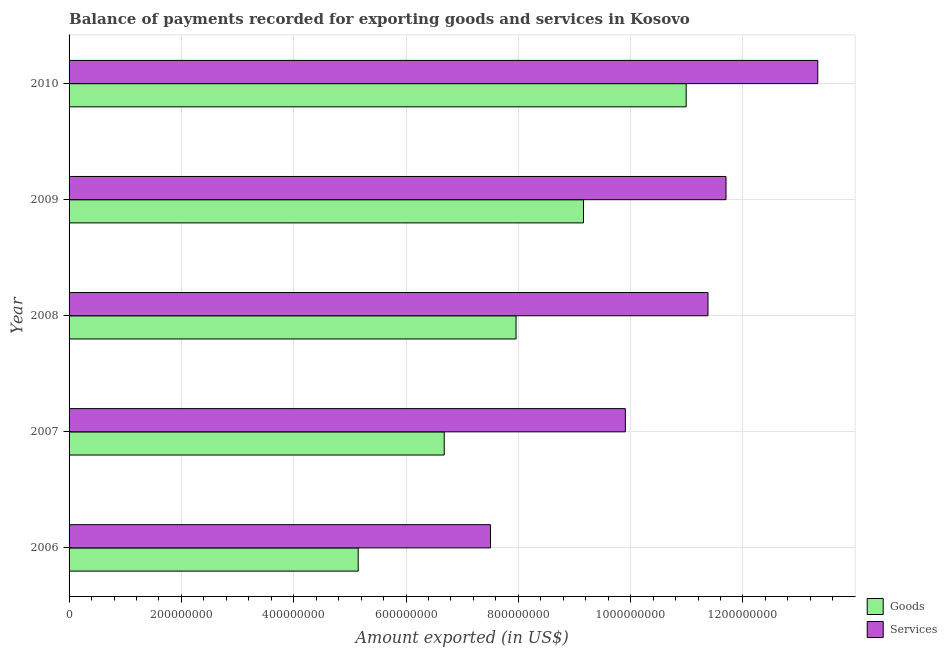How many different coloured bars are there?
Give a very brief answer. 2. How many groups of bars are there?
Provide a short and direct response. 5. Are the number of bars per tick equal to the number of legend labels?
Provide a short and direct response. Yes. Are the number of bars on each tick of the Y-axis equal?
Your response must be concise. Yes. What is the amount of services exported in 2007?
Give a very brief answer. 9.91e+08. Across all years, what is the maximum amount of goods exported?
Your response must be concise. 1.10e+09. Across all years, what is the minimum amount of goods exported?
Ensure brevity in your answer.  5.15e+08. In which year was the amount of goods exported maximum?
Provide a succinct answer. 2010. In which year was the amount of goods exported minimum?
Provide a succinct answer. 2006. What is the total amount of services exported in the graph?
Ensure brevity in your answer.  5.38e+09. What is the difference between the amount of services exported in 2007 and that in 2008?
Offer a terse response. -1.47e+08. What is the difference between the amount of services exported in 2008 and the amount of goods exported in 2010?
Offer a very short reply. 3.89e+07. What is the average amount of services exported per year?
Make the answer very short. 1.08e+09. In the year 2010, what is the difference between the amount of services exported and amount of goods exported?
Provide a short and direct response. 2.34e+08. What is the ratio of the amount of services exported in 2006 to that in 2008?
Provide a short and direct response. 0.66. Is the difference between the amount of goods exported in 2008 and 2009 greater than the difference between the amount of services exported in 2008 and 2009?
Offer a terse response. No. What is the difference between the highest and the second highest amount of services exported?
Provide a short and direct response. 1.63e+08. What is the difference between the highest and the lowest amount of goods exported?
Provide a short and direct response. 5.84e+08. Is the sum of the amount of services exported in 2008 and 2010 greater than the maximum amount of goods exported across all years?
Offer a very short reply. Yes. What does the 1st bar from the top in 2008 represents?
Keep it short and to the point. Services. What does the 2nd bar from the bottom in 2010 represents?
Provide a short and direct response. Services. How many bars are there?
Give a very brief answer. 10. What is the difference between two consecutive major ticks on the X-axis?
Offer a very short reply. 2.00e+08. Does the graph contain any zero values?
Ensure brevity in your answer.  No. How many legend labels are there?
Offer a terse response. 2. What is the title of the graph?
Make the answer very short. Balance of payments recorded for exporting goods and services in Kosovo. Does "Underweight" appear as one of the legend labels in the graph?
Ensure brevity in your answer.  No. What is the label or title of the X-axis?
Provide a succinct answer. Amount exported (in US$). What is the Amount exported (in US$) in Goods in 2006?
Offer a terse response. 5.15e+08. What is the Amount exported (in US$) of Services in 2006?
Ensure brevity in your answer.  7.50e+08. What is the Amount exported (in US$) in Goods in 2007?
Ensure brevity in your answer.  6.68e+08. What is the Amount exported (in US$) in Services in 2007?
Provide a short and direct response. 9.91e+08. What is the Amount exported (in US$) of Goods in 2008?
Your answer should be compact. 7.96e+08. What is the Amount exported (in US$) in Services in 2008?
Keep it short and to the point. 1.14e+09. What is the Amount exported (in US$) of Goods in 2009?
Make the answer very short. 9.16e+08. What is the Amount exported (in US$) in Services in 2009?
Provide a short and direct response. 1.17e+09. What is the Amount exported (in US$) in Goods in 2010?
Offer a very short reply. 1.10e+09. What is the Amount exported (in US$) of Services in 2010?
Provide a short and direct response. 1.33e+09. Across all years, what is the maximum Amount exported (in US$) of Goods?
Your response must be concise. 1.10e+09. Across all years, what is the maximum Amount exported (in US$) of Services?
Offer a very short reply. 1.33e+09. Across all years, what is the minimum Amount exported (in US$) in Goods?
Give a very brief answer. 5.15e+08. Across all years, what is the minimum Amount exported (in US$) in Services?
Make the answer very short. 7.50e+08. What is the total Amount exported (in US$) in Goods in the graph?
Your answer should be very brief. 3.99e+09. What is the total Amount exported (in US$) in Services in the graph?
Offer a very short reply. 5.38e+09. What is the difference between the Amount exported (in US$) of Goods in 2006 and that in 2007?
Your response must be concise. -1.53e+08. What is the difference between the Amount exported (in US$) of Services in 2006 and that in 2007?
Keep it short and to the point. -2.40e+08. What is the difference between the Amount exported (in US$) of Goods in 2006 and that in 2008?
Your response must be concise. -2.81e+08. What is the difference between the Amount exported (in US$) of Services in 2006 and that in 2008?
Provide a succinct answer. -3.87e+08. What is the difference between the Amount exported (in US$) in Goods in 2006 and that in 2009?
Provide a short and direct response. -4.01e+08. What is the difference between the Amount exported (in US$) in Services in 2006 and that in 2009?
Make the answer very short. -4.19e+08. What is the difference between the Amount exported (in US$) in Goods in 2006 and that in 2010?
Your response must be concise. -5.84e+08. What is the difference between the Amount exported (in US$) in Services in 2006 and that in 2010?
Make the answer very short. -5.83e+08. What is the difference between the Amount exported (in US$) of Goods in 2007 and that in 2008?
Your response must be concise. -1.28e+08. What is the difference between the Amount exported (in US$) in Services in 2007 and that in 2008?
Your answer should be compact. -1.47e+08. What is the difference between the Amount exported (in US$) in Goods in 2007 and that in 2009?
Ensure brevity in your answer.  -2.48e+08. What is the difference between the Amount exported (in US$) in Services in 2007 and that in 2009?
Make the answer very short. -1.79e+08. What is the difference between the Amount exported (in US$) of Goods in 2007 and that in 2010?
Offer a very short reply. -4.31e+08. What is the difference between the Amount exported (in US$) of Services in 2007 and that in 2010?
Your response must be concise. -3.43e+08. What is the difference between the Amount exported (in US$) of Goods in 2008 and that in 2009?
Offer a terse response. -1.20e+08. What is the difference between the Amount exported (in US$) of Services in 2008 and that in 2009?
Offer a terse response. -3.21e+07. What is the difference between the Amount exported (in US$) in Goods in 2008 and that in 2010?
Provide a succinct answer. -3.03e+08. What is the difference between the Amount exported (in US$) of Services in 2008 and that in 2010?
Give a very brief answer. -1.95e+08. What is the difference between the Amount exported (in US$) of Goods in 2009 and that in 2010?
Ensure brevity in your answer.  -1.83e+08. What is the difference between the Amount exported (in US$) in Services in 2009 and that in 2010?
Provide a short and direct response. -1.63e+08. What is the difference between the Amount exported (in US$) of Goods in 2006 and the Amount exported (in US$) of Services in 2007?
Keep it short and to the point. -4.76e+08. What is the difference between the Amount exported (in US$) in Goods in 2006 and the Amount exported (in US$) in Services in 2008?
Provide a short and direct response. -6.23e+08. What is the difference between the Amount exported (in US$) in Goods in 2006 and the Amount exported (in US$) in Services in 2009?
Your answer should be very brief. -6.55e+08. What is the difference between the Amount exported (in US$) of Goods in 2006 and the Amount exported (in US$) of Services in 2010?
Your response must be concise. -8.18e+08. What is the difference between the Amount exported (in US$) in Goods in 2007 and the Amount exported (in US$) in Services in 2008?
Provide a short and direct response. -4.70e+08. What is the difference between the Amount exported (in US$) of Goods in 2007 and the Amount exported (in US$) of Services in 2009?
Your answer should be very brief. -5.02e+08. What is the difference between the Amount exported (in US$) in Goods in 2007 and the Amount exported (in US$) in Services in 2010?
Provide a short and direct response. -6.65e+08. What is the difference between the Amount exported (in US$) in Goods in 2008 and the Amount exported (in US$) in Services in 2009?
Make the answer very short. -3.74e+08. What is the difference between the Amount exported (in US$) in Goods in 2008 and the Amount exported (in US$) in Services in 2010?
Provide a succinct answer. -5.37e+08. What is the difference between the Amount exported (in US$) of Goods in 2009 and the Amount exported (in US$) of Services in 2010?
Offer a terse response. -4.17e+08. What is the average Amount exported (in US$) in Goods per year?
Provide a short and direct response. 7.99e+08. What is the average Amount exported (in US$) of Services per year?
Make the answer very short. 1.08e+09. In the year 2006, what is the difference between the Amount exported (in US$) of Goods and Amount exported (in US$) of Services?
Offer a very short reply. -2.36e+08. In the year 2007, what is the difference between the Amount exported (in US$) of Goods and Amount exported (in US$) of Services?
Provide a short and direct response. -3.23e+08. In the year 2008, what is the difference between the Amount exported (in US$) of Goods and Amount exported (in US$) of Services?
Offer a very short reply. -3.42e+08. In the year 2009, what is the difference between the Amount exported (in US$) in Goods and Amount exported (in US$) in Services?
Offer a very short reply. -2.54e+08. In the year 2010, what is the difference between the Amount exported (in US$) in Goods and Amount exported (in US$) in Services?
Your answer should be compact. -2.34e+08. What is the ratio of the Amount exported (in US$) in Goods in 2006 to that in 2007?
Your response must be concise. 0.77. What is the ratio of the Amount exported (in US$) in Services in 2006 to that in 2007?
Your answer should be compact. 0.76. What is the ratio of the Amount exported (in US$) of Goods in 2006 to that in 2008?
Offer a very short reply. 0.65. What is the ratio of the Amount exported (in US$) of Services in 2006 to that in 2008?
Your response must be concise. 0.66. What is the ratio of the Amount exported (in US$) of Goods in 2006 to that in 2009?
Keep it short and to the point. 0.56. What is the ratio of the Amount exported (in US$) of Services in 2006 to that in 2009?
Offer a very short reply. 0.64. What is the ratio of the Amount exported (in US$) in Goods in 2006 to that in 2010?
Your answer should be compact. 0.47. What is the ratio of the Amount exported (in US$) in Services in 2006 to that in 2010?
Your answer should be compact. 0.56. What is the ratio of the Amount exported (in US$) in Goods in 2007 to that in 2008?
Make the answer very short. 0.84. What is the ratio of the Amount exported (in US$) of Services in 2007 to that in 2008?
Ensure brevity in your answer.  0.87. What is the ratio of the Amount exported (in US$) in Goods in 2007 to that in 2009?
Give a very brief answer. 0.73. What is the ratio of the Amount exported (in US$) of Services in 2007 to that in 2009?
Your answer should be very brief. 0.85. What is the ratio of the Amount exported (in US$) in Goods in 2007 to that in 2010?
Make the answer very short. 0.61. What is the ratio of the Amount exported (in US$) of Services in 2007 to that in 2010?
Your response must be concise. 0.74. What is the ratio of the Amount exported (in US$) in Goods in 2008 to that in 2009?
Your answer should be compact. 0.87. What is the ratio of the Amount exported (in US$) in Services in 2008 to that in 2009?
Your answer should be very brief. 0.97. What is the ratio of the Amount exported (in US$) of Goods in 2008 to that in 2010?
Provide a succinct answer. 0.72. What is the ratio of the Amount exported (in US$) of Services in 2008 to that in 2010?
Provide a short and direct response. 0.85. What is the ratio of the Amount exported (in US$) in Goods in 2009 to that in 2010?
Your response must be concise. 0.83. What is the ratio of the Amount exported (in US$) in Services in 2009 to that in 2010?
Your answer should be very brief. 0.88. What is the difference between the highest and the second highest Amount exported (in US$) in Goods?
Your answer should be very brief. 1.83e+08. What is the difference between the highest and the second highest Amount exported (in US$) of Services?
Your answer should be very brief. 1.63e+08. What is the difference between the highest and the lowest Amount exported (in US$) in Goods?
Your response must be concise. 5.84e+08. What is the difference between the highest and the lowest Amount exported (in US$) of Services?
Your answer should be very brief. 5.83e+08. 